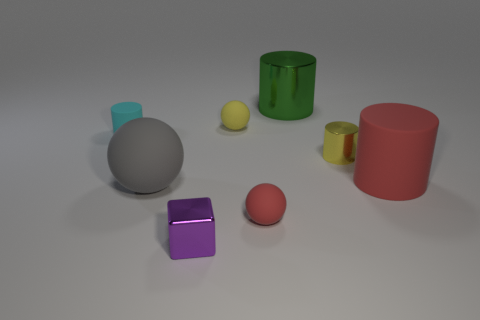Add 1 tiny yellow objects. How many objects exist? 9 Subtract all blocks. How many objects are left? 7 Subtract all yellow objects. Subtract all matte cylinders. How many objects are left? 4 Add 2 small purple things. How many small purple things are left? 3 Add 3 big cyan matte objects. How many big cyan matte objects exist? 3 Subtract 0 green balls. How many objects are left? 8 